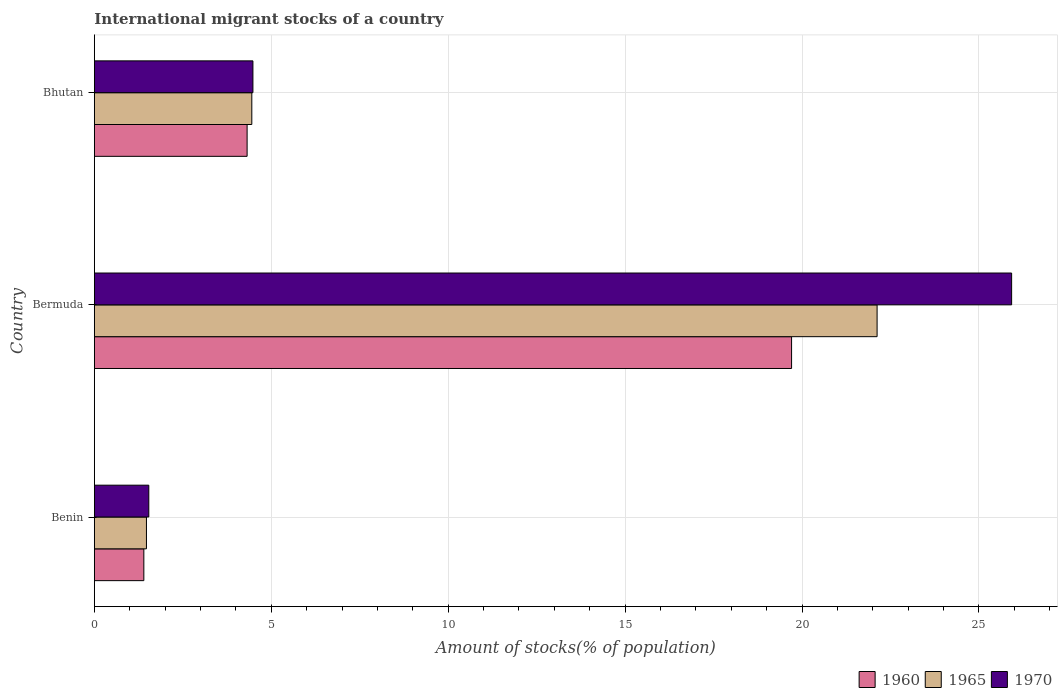How many different coloured bars are there?
Ensure brevity in your answer.  3. Are the number of bars per tick equal to the number of legend labels?
Offer a terse response. Yes. What is the label of the 1st group of bars from the top?
Give a very brief answer. Bhutan. What is the amount of stocks in in 1960 in Bhutan?
Your answer should be very brief. 4.32. Across all countries, what is the maximum amount of stocks in in 1960?
Make the answer very short. 19.7. Across all countries, what is the minimum amount of stocks in in 1960?
Offer a very short reply. 1.4. In which country was the amount of stocks in in 1965 maximum?
Ensure brevity in your answer.  Bermuda. In which country was the amount of stocks in in 1960 minimum?
Offer a very short reply. Benin. What is the total amount of stocks in in 1965 in the graph?
Offer a terse response. 28.05. What is the difference between the amount of stocks in in 1965 in Benin and that in Bermuda?
Offer a terse response. -20.65. What is the difference between the amount of stocks in in 1965 in Bhutan and the amount of stocks in in 1970 in Bermuda?
Keep it short and to the point. -21.47. What is the average amount of stocks in in 1970 per country?
Your answer should be compact. 10.65. What is the difference between the amount of stocks in in 1965 and amount of stocks in in 1970 in Bermuda?
Your response must be concise. -3.8. In how many countries, is the amount of stocks in in 1965 greater than 26 %?
Provide a succinct answer. 0. What is the ratio of the amount of stocks in in 1970 in Bermuda to that in Bhutan?
Keep it short and to the point. 5.78. Is the amount of stocks in in 1970 in Benin less than that in Bhutan?
Make the answer very short. Yes. What is the difference between the highest and the second highest amount of stocks in in 1965?
Make the answer very short. 17.67. What is the difference between the highest and the lowest amount of stocks in in 1960?
Your answer should be very brief. 18.31. In how many countries, is the amount of stocks in in 1965 greater than the average amount of stocks in in 1965 taken over all countries?
Keep it short and to the point. 1. Is the sum of the amount of stocks in in 1970 in Bermuda and Bhutan greater than the maximum amount of stocks in in 1960 across all countries?
Your answer should be very brief. Yes. What does the 2nd bar from the top in Benin represents?
Provide a short and direct response. 1965. What does the 2nd bar from the bottom in Bermuda represents?
Give a very brief answer. 1965. Are all the bars in the graph horizontal?
Ensure brevity in your answer.  Yes. Where does the legend appear in the graph?
Your response must be concise. Bottom right. How many legend labels are there?
Make the answer very short. 3. What is the title of the graph?
Ensure brevity in your answer.  International migrant stocks of a country. Does "1963" appear as one of the legend labels in the graph?
Ensure brevity in your answer.  No. What is the label or title of the X-axis?
Offer a very short reply. Amount of stocks(% of population). What is the label or title of the Y-axis?
Keep it short and to the point. Country. What is the Amount of stocks(% of population) of 1960 in Benin?
Make the answer very short. 1.4. What is the Amount of stocks(% of population) in 1965 in Benin?
Make the answer very short. 1.47. What is the Amount of stocks(% of population) of 1970 in Benin?
Offer a terse response. 1.54. What is the Amount of stocks(% of population) of 1960 in Bermuda?
Keep it short and to the point. 19.7. What is the Amount of stocks(% of population) in 1965 in Bermuda?
Your answer should be very brief. 22.12. What is the Amount of stocks(% of population) of 1970 in Bermuda?
Provide a succinct answer. 25.92. What is the Amount of stocks(% of population) of 1960 in Bhutan?
Your answer should be compact. 4.32. What is the Amount of stocks(% of population) in 1965 in Bhutan?
Give a very brief answer. 4.45. What is the Amount of stocks(% of population) of 1970 in Bhutan?
Your answer should be very brief. 4.48. Across all countries, what is the maximum Amount of stocks(% of population) of 1960?
Make the answer very short. 19.7. Across all countries, what is the maximum Amount of stocks(% of population) in 1965?
Your response must be concise. 22.12. Across all countries, what is the maximum Amount of stocks(% of population) in 1970?
Offer a terse response. 25.92. Across all countries, what is the minimum Amount of stocks(% of population) in 1960?
Give a very brief answer. 1.4. Across all countries, what is the minimum Amount of stocks(% of population) of 1965?
Your response must be concise. 1.47. Across all countries, what is the minimum Amount of stocks(% of population) in 1970?
Give a very brief answer. 1.54. What is the total Amount of stocks(% of population) in 1960 in the graph?
Your answer should be compact. 25.42. What is the total Amount of stocks(% of population) of 1965 in the graph?
Offer a terse response. 28.05. What is the total Amount of stocks(% of population) of 1970 in the graph?
Offer a terse response. 31.94. What is the difference between the Amount of stocks(% of population) of 1960 in Benin and that in Bermuda?
Keep it short and to the point. -18.31. What is the difference between the Amount of stocks(% of population) of 1965 in Benin and that in Bermuda?
Make the answer very short. -20.65. What is the difference between the Amount of stocks(% of population) of 1970 in Benin and that in Bermuda?
Keep it short and to the point. -24.38. What is the difference between the Amount of stocks(% of population) of 1960 in Benin and that in Bhutan?
Your answer should be very brief. -2.92. What is the difference between the Amount of stocks(% of population) in 1965 in Benin and that in Bhutan?
Keep it short and to the point. -2.98. What is the difference between the Amount of stocks(% of population) of 1970 in Benin and that in Bhutan?
Make the answer very short. -2.94. What is the difference between the Amount of stocks(% of population) of 1960 in Bermuda and that in Bhutan?
Your answer should be very brief. 15.39. What is the difference between the Amount of stocks(% of population) in 1965 in Bermuda and that in Bhutan?
Your response must be concise. 17.67. What is the difference between the Amount of stocks(% of population) in 1970 in Bermuda and that in Bhutan?
Your response must be concise. 21.44. What is the difference between the Amount of stocks(% of population) in 1960 in Benin and the Amount of stocks(% of population) in 1965 in Bermuda?
Make the answer very short. -20.72. What is the difference between the Amount of stocks(% of population) of 1960 in Benin and the Amount of stocks(% of population) of 1970 in Bermuda?
Offer a terse response. -24.52. What is the difference between the Amount of stocks(% of population) of 1965 in Benin and the Amount of stocks(% of population) of 1970 in Bermuda?
Keep it short and to the point. -24.45. What is the difference between the Amount of stocks(% of population) in 1960 in Benin and the Amount of stocks(% of population) in 1965 in Bhutan?
Keep it short and to the point. -3.05. What is the difference between the Amount of stocks(% of population) in 1960 in Benin and the Amount of stocks(% of population) in 1970 in Bhutan?
Give a very brief answer. -3.08. What is the difference between the Amount of stocks(% of population) in 1965 in Benin and the Amount of stocks(% of population) in 1970 in Bhutan?
Keep it short and to the point. -3.01. What is the difference between the Amount of stocks(% of population) in 1960 in Bermuda and the Amount of stocks(% of population) in 1965 in Bhutan?
Make the answer very short. 15.25. What is the difference between the Amount of stocks(% of population) in 1960 in Bermuda and the Amount of stocks(% of population) in 1970 in Bhutan?
Your answer should be very brief. 15.22. What is the difference between the Amount of stocks(% of population) in 1965 in Bermuda and the Amount of stocks(% of population) in 1970 in Bhutan?
Your answer should be compact. 17.64. What is the average Amount of stocks(% of population) of 1960 per country?
Ensure brevity in your answer.  8.47. What is the average Amount of stocks(% of population) in 1965 per country?
Keep it short and to the point. 9.35. What is the average Amount of stocks(% of population) in 1970 per country?
Your answer should be compact. 10.65. What is the difference between the Amount of stocks(% of population) of 1960 and Amount of stocks(% of population) of 1965 in Benin?
Offer a terse response. -0.07. What is the difference between the Amount of stocks(% of population) in 1960 and Amount of stocks(% of population) in 1970 in Benin?
Ensure brevity in your answer.  -0.14. What is the difference between the Amount of stocks(% of population) in 1965 and Amount of stocks(% of population) in 1970 in Benin?
Ensure brevity in your answer.  -0.07. What is the difference between the Amount of stocks(% of population) of 1960 and Amount of stocks(% of population) of 1965 in Bermuda?
Your response must be concise. -2.42. What is the difference between the Amount of stocks(% of population) of 1960 and Amount of stocks(% of population) of 1970 in Bermuda?
Your answer should be very brief. -6.22. What is the difference between the Amount of stocks(% of population) of 1965 and Amount of stocks(% of population) of 1970 in Bermuda?
Give a very brief answer. -3.8. What is the difference between the Amount of stocks(% of population) of 1960 and Amount of stocks(% of population) of 1965 in Bhutan?
Offer a terse response. -0.13. What is the difference between the Amount of stocks(% of population) in 1960 and Amount of stocks(% of population) in 1970 in Bhutan?
Make the answer very short. -0.16. What is the difference between the Amount of stocks(% of population) in 1965 and Amount of stocks(% of population) in 1970 in Bhutan?
Ensure brevity in your answer.  -0.03. What is the ratio of the Amount of stocks(% of population) of 1960 in Benin to that in Bermuda?
Keep it short and to the point. 0.07. What is the ratio of the Amount of stocks(% of population) in 1965 in Benin to that in Bermuda?
Provide a succinct answer. 0.07. What is the ratio of the Amount of stocks(% of population) in 1970 in Benin to that in Bermuda?
Give a very brief answer. 0.06. What is the ratio of the Amount of stocks(% of population) of 1960 in Benin to that in Bhutan?
Provide a short and direct response. 0.32. What is the ratio of the Amount of stocks(% of population) in 1965 in Benin to that in Bhutan?
Provide a short and direct response. 0.33. What is the ratio of the Amount of stocks(% of population) of 1970 in Benin to that in Bhutan?
Offer a terse response. 0.34. What is the ratio of the Amount of stocks(% of population) in 1960 in Bermuda to that in Bhutan?
Provide a succinct answer. 4.56. What is the ratio of the Amount of stocks(% of population) in 1965 in Bermuda to that in Bhutan?
Give a very brief answer. 4.97. What is the ratio of the Amount of stocks(% of population) of 1970 in Bermuda to that in Bhutan?
Offer a terse response. 5.78. What is the difference between the highest and the second highest Amount of stocks(% of population) of 1960?
Offer a very short reply. 15.39. What is the difference between the highest and the second highest Amount of stocks(% of population) in 1965?
Your answer should be compact. 17.67. What is the difference between the highest and the second highest Amount of stocks(% of population) of 1970?
Provide a succinct answer. 21.44. What is the difference between the highest and the lowest Amount of stocks(% of population) in 1960?
Ensure brevity in your answer.  18.31. What is the difference between the highest and the lowest Amount of stocks(% of population) in 1965?
Your answer should be very brief. 20.65. What is the difference between the highest and the lowest Amount of stocks(% of population) in 1970?
Ensure brevity in your answer.  24.38. 